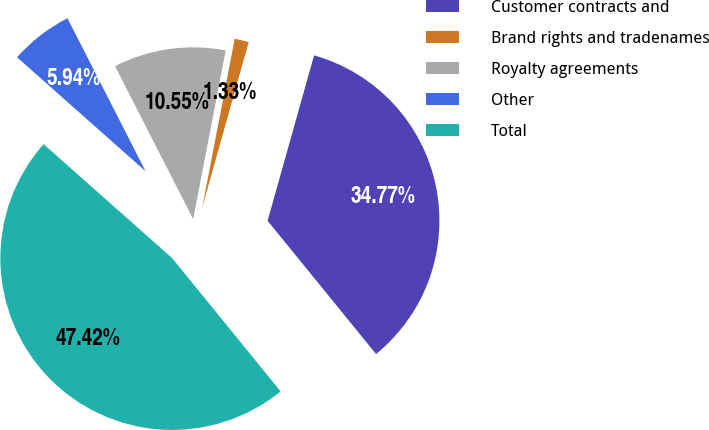<chart> <loc_0><loc_0><loc_500><loc_500><pie_chart><fcel>Customer contracts and<fcel>Brand rights and tradenames<fcel>Royalty agreements<fcel>Other<fcel>Total<nl><fcel>34.77%<fcel>1.33%<fcel>10.55%<fcel>5.94%<fcel>47.42%<nl></chart> 